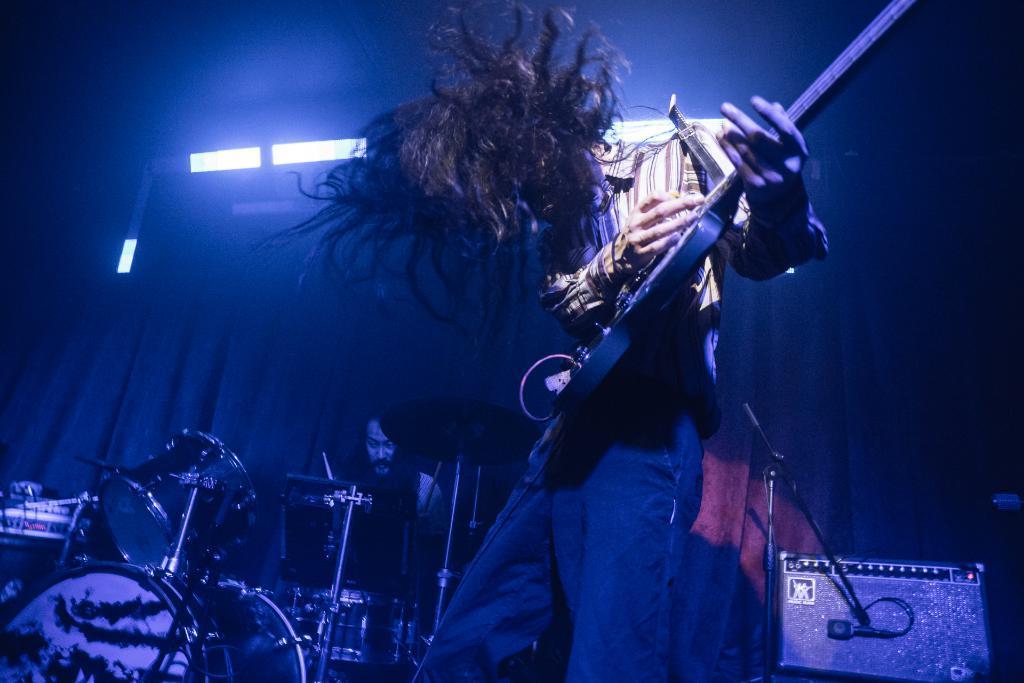How would you summarize this image in a sentence or two? In this image a man is playing guitar. Beside him another person is playing drums. There is speaker in the right. In the background there is curtain and lights. 